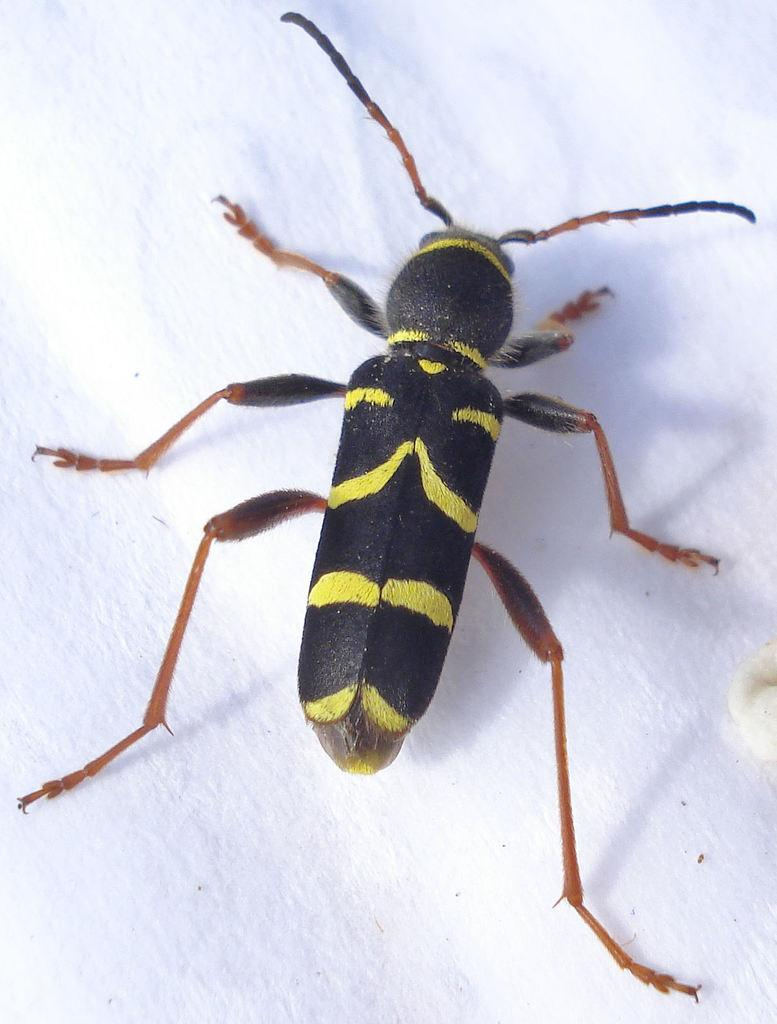What type of creature is present in the image? There is an insect in the image. What type of instrument is the minister playing in the image? There is no minister or instrument present in the image; it only features an insect. 